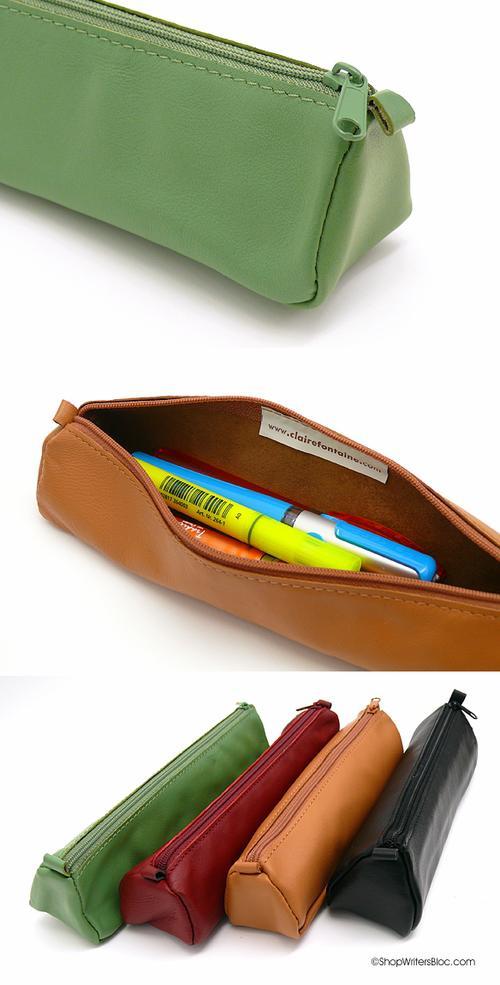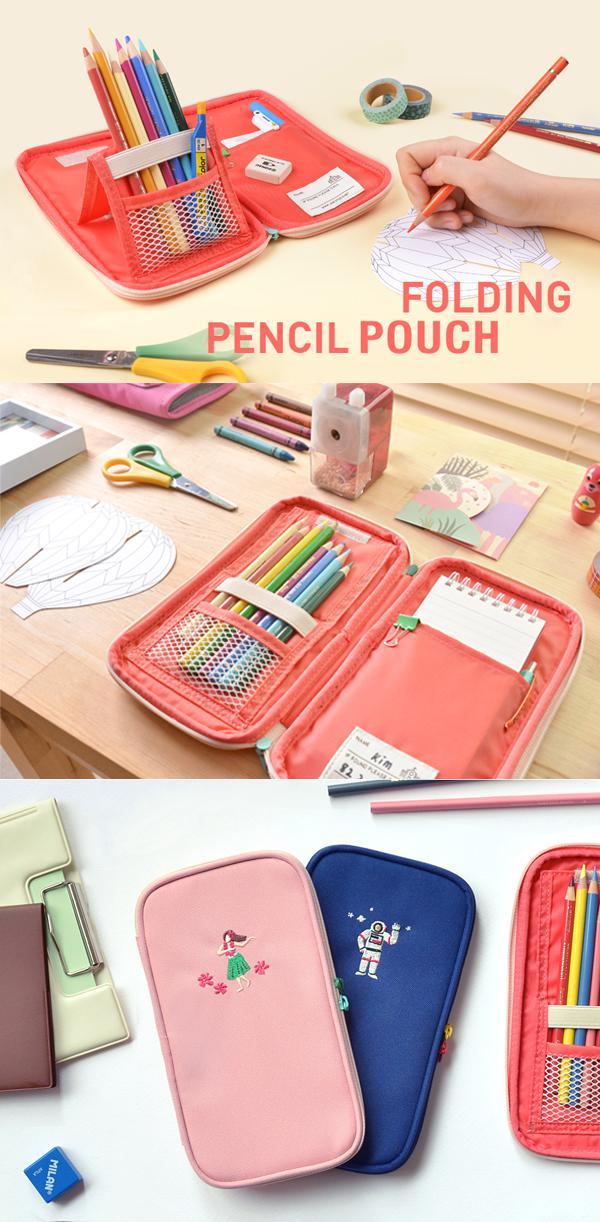The first image is the image on the left, the second image is the image on the right. Analyze the images presented: Is the assertion "Two light blue pencil bags are unzipped and showing the inside." valid? Answer yes or no. No. The first image is the image on the left, the second image is the image on the right. Considering the images on both sides, is "there is a mesh pocket on the front of a pencil case" valid? Answer yes or no. No. 